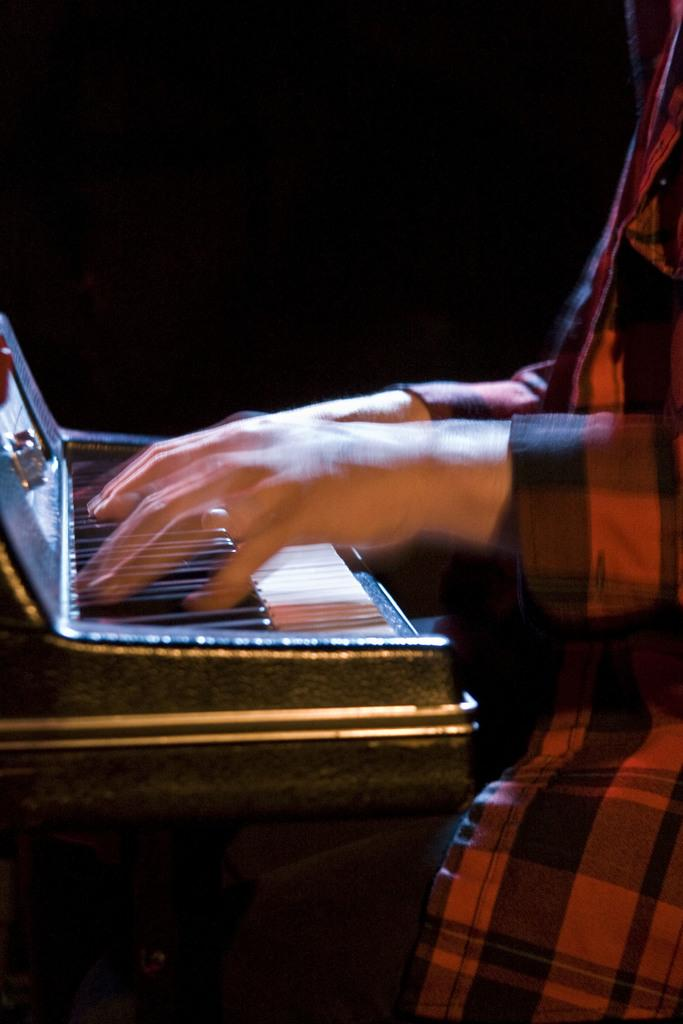What is happening in the image? There is a person in the image who is playing a musical instrument. Can you describe the person in the image? Unfortunately, the image does not provide enough detail to describe the person. What type of musical instrument is the person playing? The specific type of musical instrument is not mentioned in the facts provided. What color is the nail on the chair in the image? There is no mention of a nail or a chair in the image, so this question cannot be answered. 